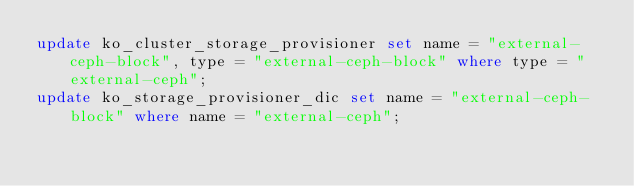<code> <loc_0><loc_0><loc_500><loc_500><_SQL_>update ko_cluster_storage_provisioner set name = "external-ceph-block", type = "external-ceph-block" where type = "external-ceph";
update ko_storage_provisioner_dic set name = "external-ceph-block" where name = "external-ceph";
</code> 